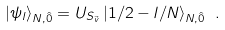Convert formula to latex. <formula><loc_0><loc_0><loc_500><loc_500>| \psi _ { l } \rangle _ { N , \hat { 0 } } = U _ { S _ { \vec { v } } } \, | 1 / 2 - l / N \rangle _ { N , \hat { 0 } } \ .</formula> 